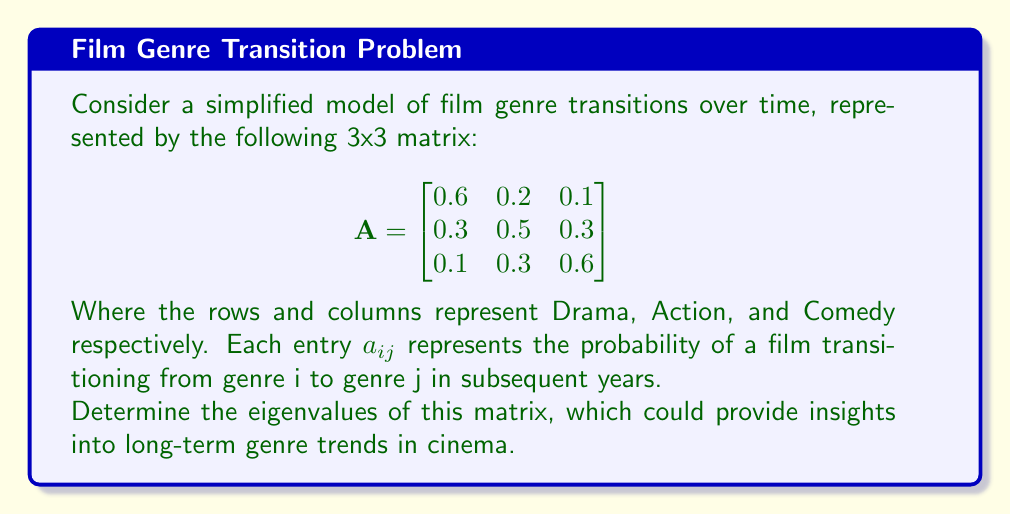Solve this math problem. To find the eigenvalues of matrix A, we need to solve the characteristic equation:

$\det(A - \lambda I) = 0$

Where $I$ is the 3x3 identity matrix and $\lambda$ represents the eigenvalues.

Step 1: Set up the characteristic equation:

$$\det\begin{pmatrix}
0.6-\lambda & 0.2 & 0.1 \\
0.3 & 0.5-\lambda & 0.3 \\
0.1 & 0.3 & 0.6-\lambda
\end{pmatrix} = 0$$

Step 2: Expand the determinant:

$(0.6-\lambda)[(0.5-\lambda)(0.6-\lambda) - 0.09] - 0.2[0.3(0.6-\lambda) - 0.03] + 0.1[0.3(0.5-\lambda) - 0.09] = 0$

Step 3: Simplify:

$-\lambda^3 + 1.7\lambda^2 - 0.83\lambda + 0.13 = 0$

Step 4: This cubic equation can be solved using the cubic formula or numerical methods. Using a computer algebra system, we find the roots:

$\lambda_1 \approx 1$
$\lambda_2 \approx 0.4472$
$\lambda_3 \approx 0.2528$

These eigenvalues provide insights into the long-term behavior of genre transitions. The largest eigenvalue (1) suggests a stable distribution of genres over time, while the other two eigenvalues indicate rates of convergence to this distribution.
Answer: $\lambda_1 = 1$, $\lambda_2 \approx 0.4472$, $\lambda_3 \approx 0.2528$ 